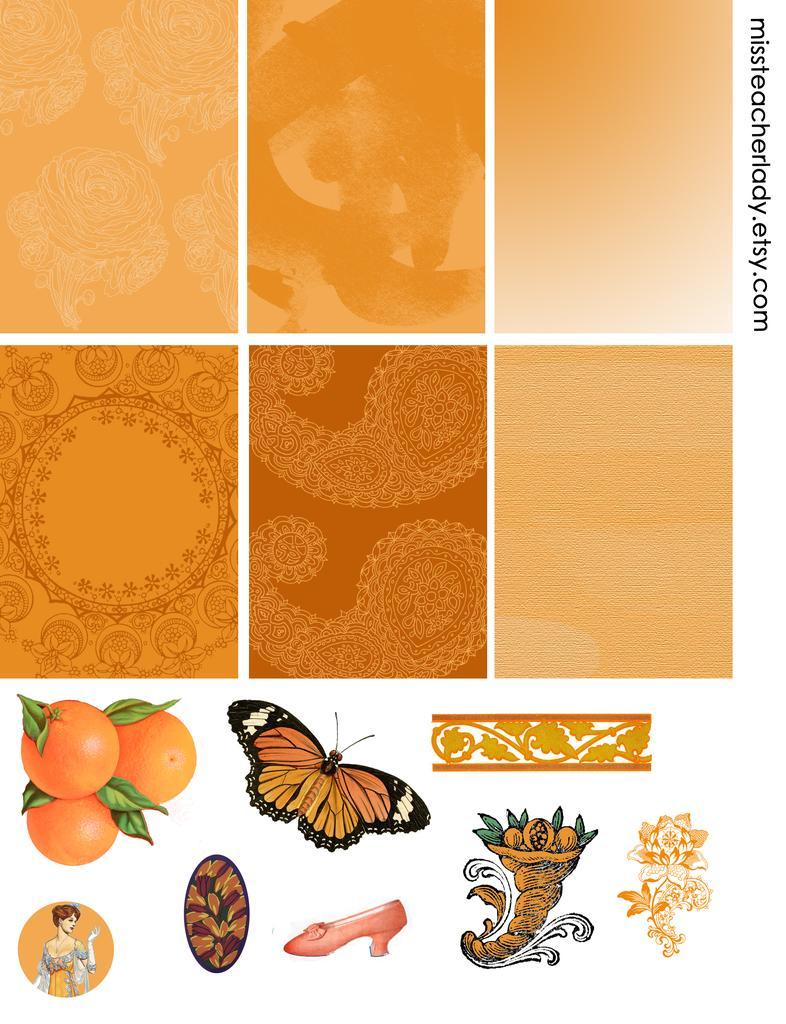Please provide a concise description of this image. This is the college image. We can see orange, butterfly, some designs and shoe at the bottom. 